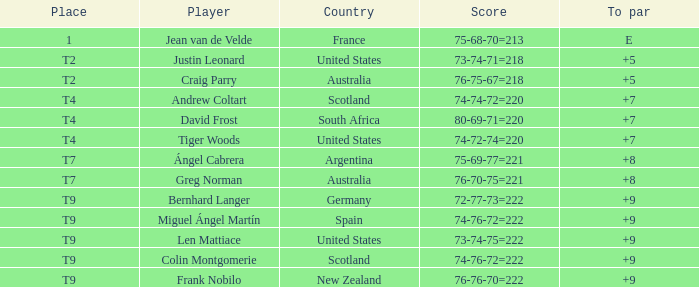What is the place number for the player with a To Par score of 'E'? 1.0. Parse the table in full. {'header': ['Place', 'Player', 'Country', 'Score', 'To par'], 'rows': [['1', 'Jean van de Velde', 'France', '75-68-70=213', 'E'], ['T2', 'Justin Leonard', 'United States', '73-74-71=218', '+5'], ['T2', 'Craig Parry', 'Australia', '76-75-67=218', '+5'], ['T4', 'Andrew Coltart', 'Scotland', '74-74-72=220', '+7'], ['T4', 'David Frost', 'South Africa', '80-69-71=220', '+7'], ['T4', 'Tiger Woods', 'United States', '74-72-74=220', '+7'], ['T7', 'Ángel Cabrera', 'Argentina', '75-69-77=221', '+8'], ['T7', 'Greg Norman', 'Australia', '76-70-75=221', '+8'], ['T9', 'Bernhard Langer', 'Germany', '72-77-73=222', '+9'], ['T9', 'Miguel Ángel Martín', 'Spain', '74-76-72=222', '+9'], ['T9', 'Len Mattiace', 'United States', '73-74-75=222', '+9'], ['T9', 'Colin Montgomerie', 'Scotland', '74-76-72=222', '+9'], ['T9', 'Frank Nobilo', 'New Zealand', '76-76-70=222', '+9']]} 